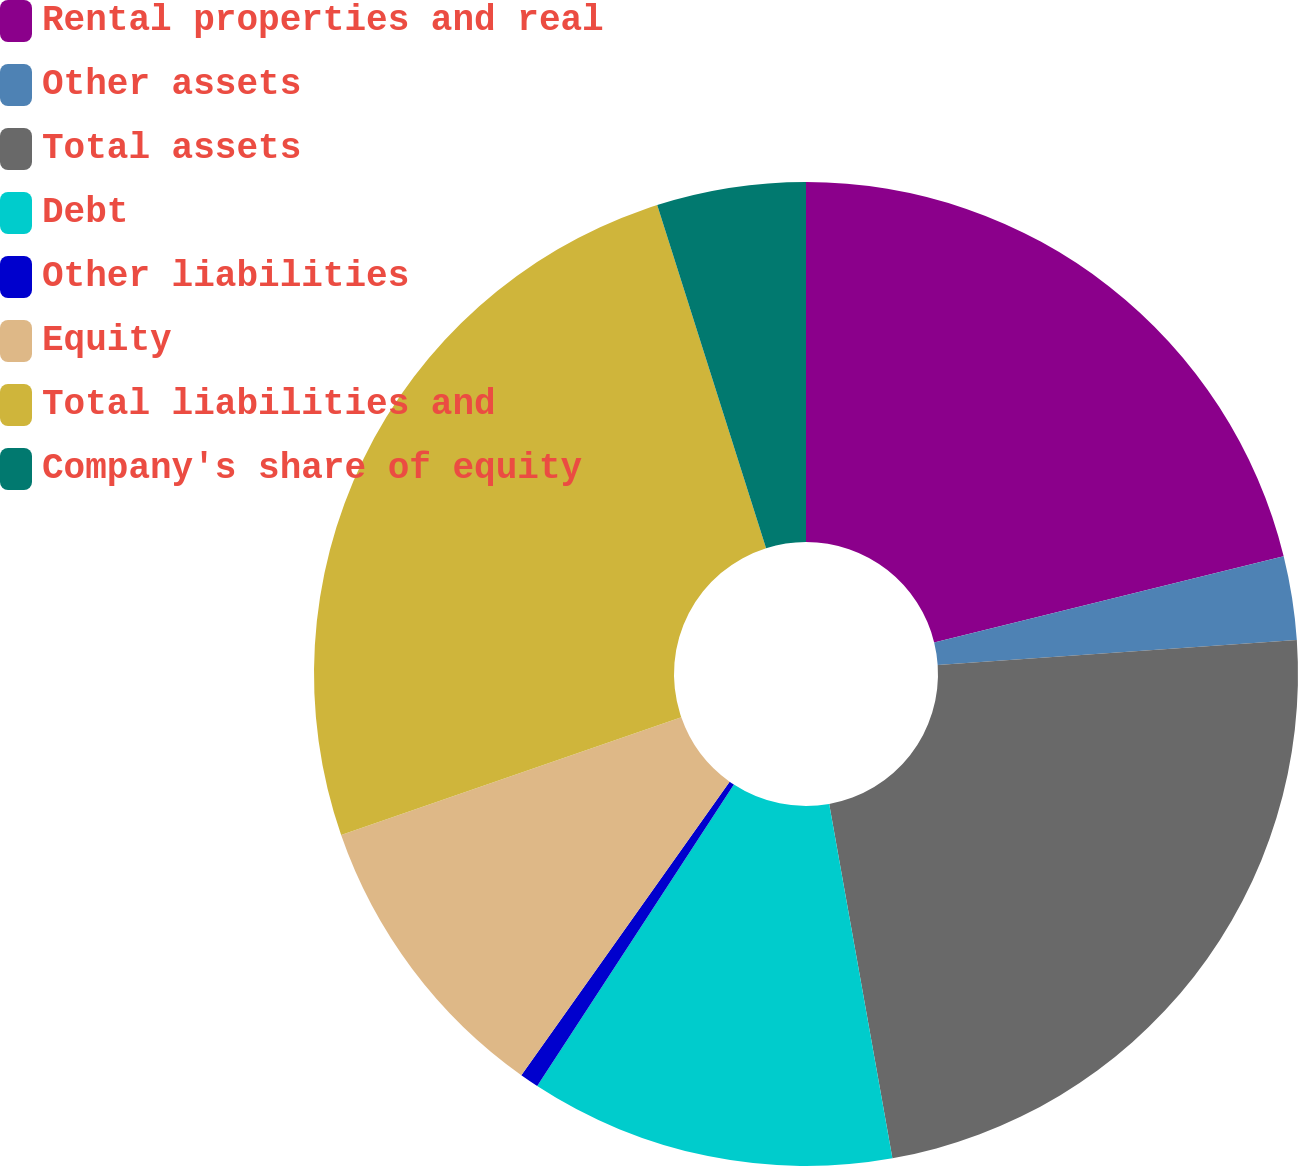Convert chart to OTSL. <chart><loc_0><loc_0><loc_500><loc_500><pie_chart><fcel>Rental properties and real<fcel>Other assets<fcel>Total assets<fcel>Debt<fcel>Other liabilities<fcel>Equity<fcel>Total liabilities and<fcel>Company's share of equity<nl><fcel>21.15%<fcel>2.75%<fcel>23.29%<fcel>12.01%<fcel>0.62%<fcel>9.87%<fcel>25.42%<fcel>4.89%<nl></chart> 